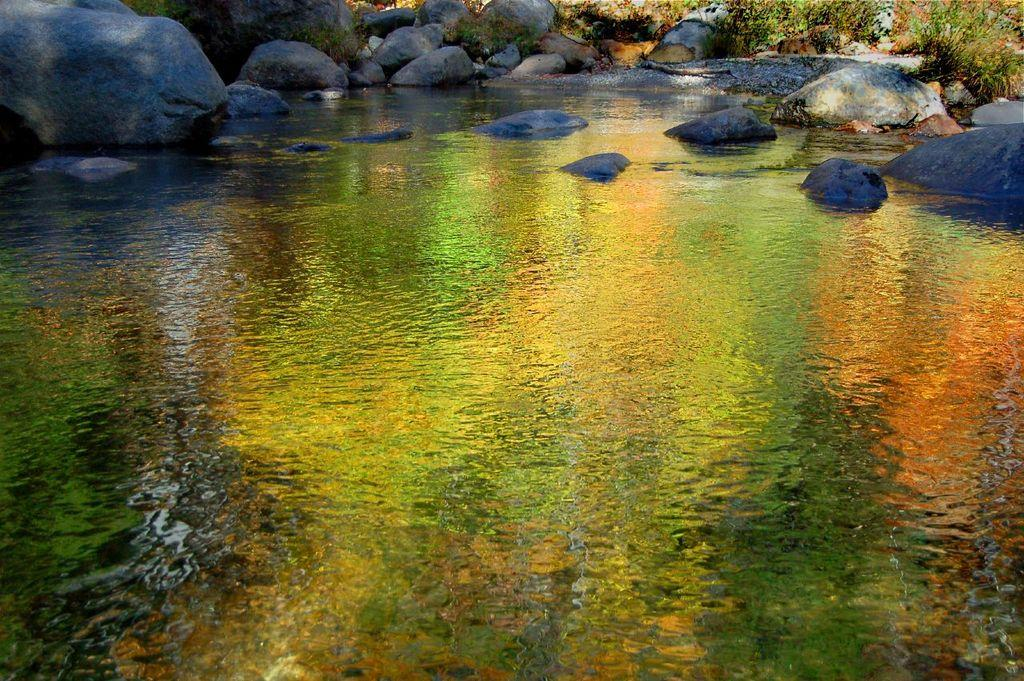What is the primary element in the image? There is a water surface in the image. What can be seen in the water in the image? There are rocks visible in the image. What type of vegetation is present in the image? There are plants in the image. What type of fan is visible in the image? There is no fan present in the image. How many balls can be seen in the image? There are no balls present in the image. 